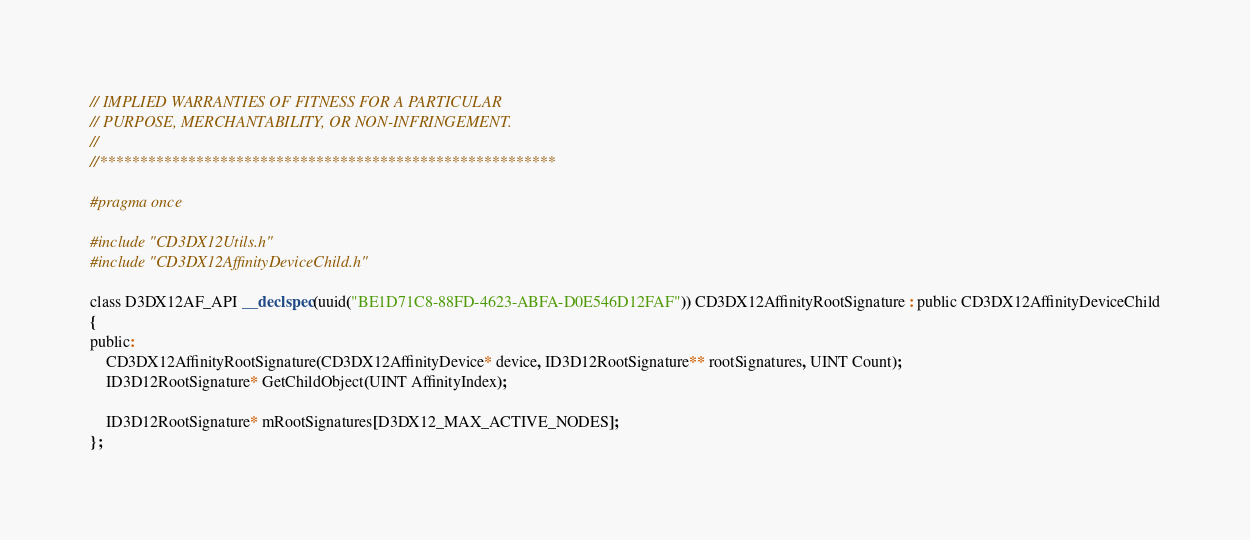<code> <loc_0><loc_0><loc_500><loc_500><_C_>// IMPLIED WARRANTIES OF FITNESS FOR A PARTICULAR
// PURPOSE, MERCHANTABILITY, OR NON-INFRINGEMENT.
//
//*********************************************************

#pragma once

#include "CD3DX12Utils.h"
#include "CD3DX12AffinityDeviceChild.h"

class D3DX12AF_API __declspec(uuid("BE1D71C8-88FD-4623-ABFA-D0E546D12FAF")) CD3DX12AffinityRootSignature : public CD3DX12AffinityDeviceChild
{
public:
    CD3DX12AffinityRootSignature(CD3DX12AffinityDevice* device, ID3D12RootSignature** rootSignatures, UINT Count);
    ID3D12RootSignature* GetChildObject(UINT AffinityIndex);

    ID3D12RootSignature* mRootSignatures[D3DX12_MAX_ACTIVE_NODES];
};
</code> 